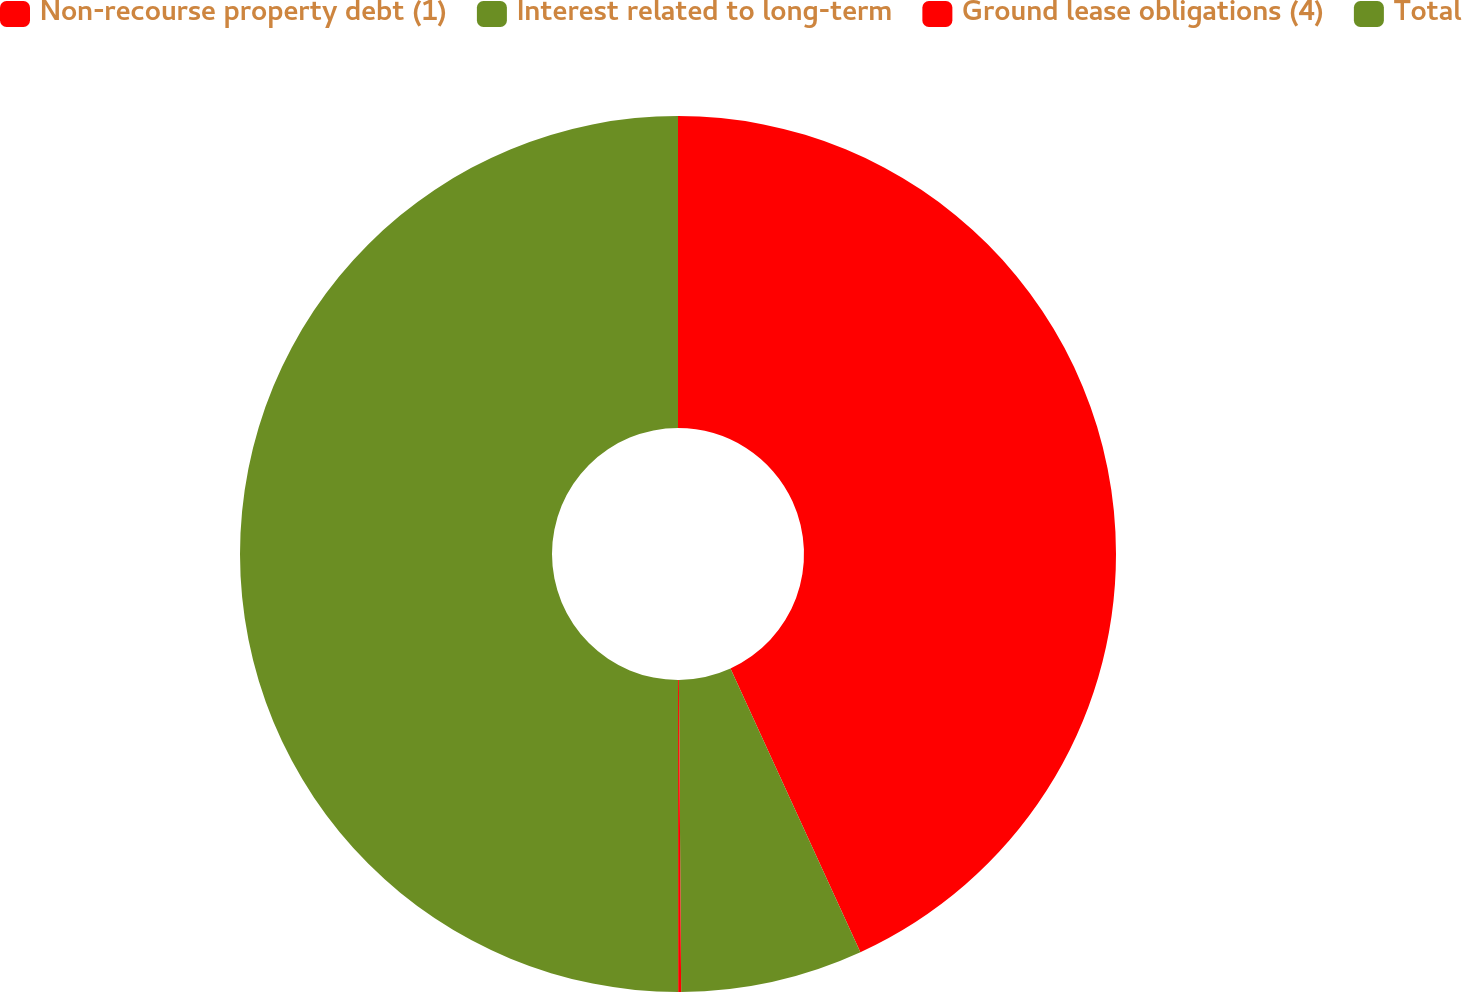Convert chart to OTSL. <chart><loc_0><loc_0><loc_500><loc_500><pie_chart><fcel>Non-recourse property debt (1)<fcel>Interest related to long-term<fcel>Ground lease obligations (4)<fcel>Total<nl><fcel>43.16%<fcel>6.72%<fcel>0.11%<fcel>50.0%<nl></chart> 